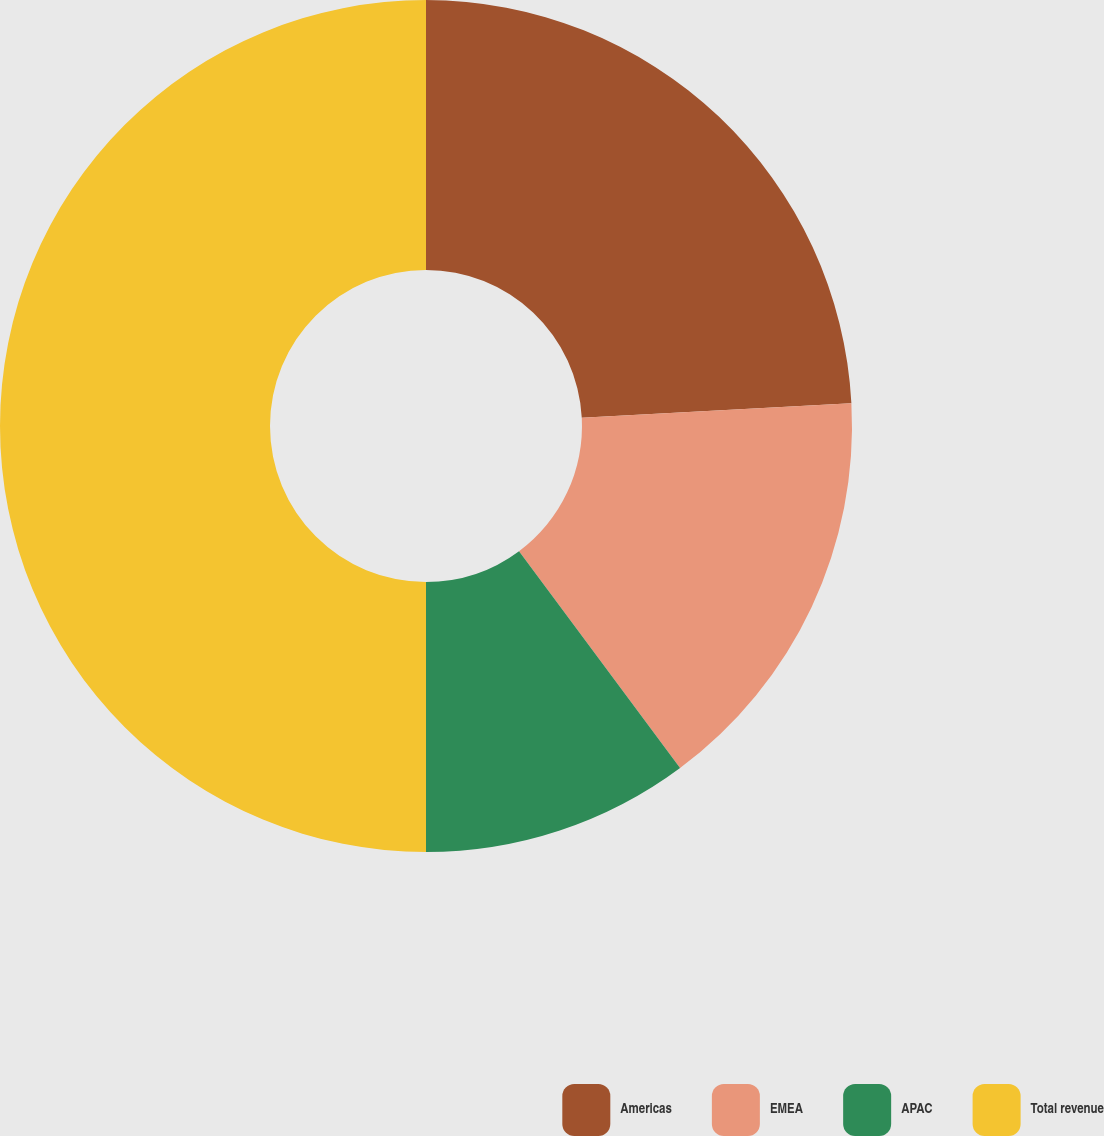<chart> <loc_0><loc_0><loc_500><loc_500><pie_chart><fcel>Americas<fcel>EMEA<fcel>APAC<fcel>Total revenue<nl><fcel>24.15%<fcel>15.68%<fcel>10.17%<fcel>50.0%<nl></chart> 